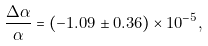Convert formula to latex. <formula><loc_0><loc_0><loc_500><loc_500>\frac { \Delta \alpha } { \alpha } = ( - 1 . 0 9 \pm 0 . 3 6 ) \times 1 0 ^ { - 5 } ,</formula> 